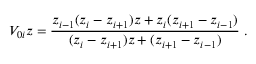<formula> <loc_0><loc_0><loc_500><loc_500>V _ { 0 i } z = \frac { z _ { i - 1 } ( z _ { i } - z _ { i + 1 } ) z + z _ { i } ( z _ { i + 1 } - z _ { i - 1 } ) } { ( z _ { i } - z _ { i + 1 } ) z + ( z _ { i + 1 } - z _ { i - 1 } ) } \ .</formula> 